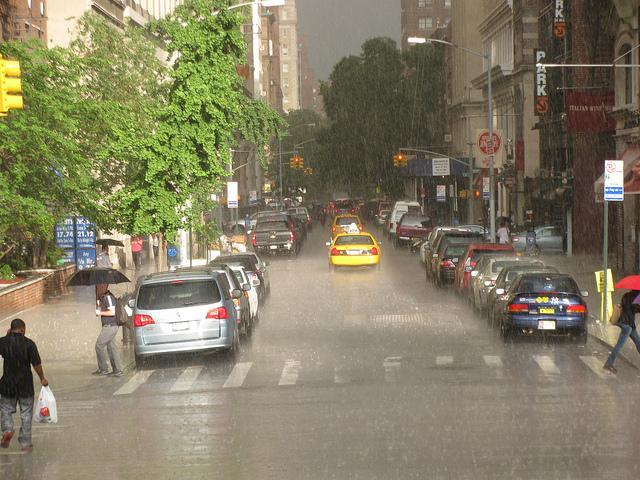What type markings are shown here?

Choices:
A) cross walk
B) stop message
C) zoo ads
D) abbey road cross walk 